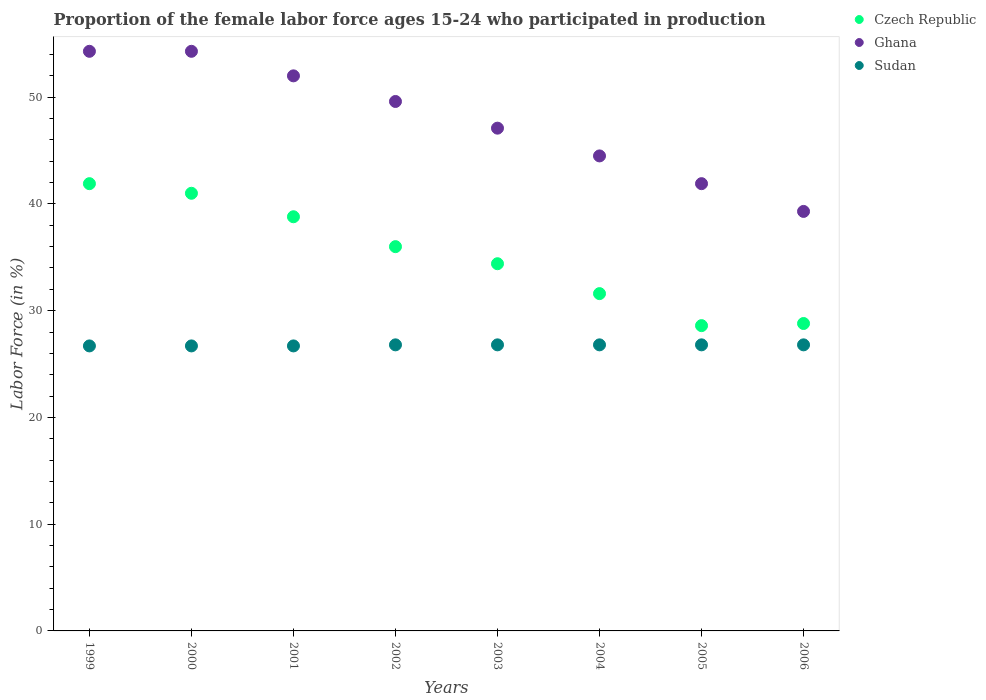What is the proportion of the female labor force who participated in production in Ghana in 2003?
Offer a very short reply. 47.1. Across all years, what is the maximum proportion of the female labor force who participated in production in Ghana?
Provide a succinct answer. 54.3. Across all years, what is the minimum proportion of the female labor force who participated in production in Ghana?
Your answer should be very brief. 39.3. What is the total proportion of the female labor force who participated in production in Czech Republic in the graph?
Your answer should be compact. 281.1. What is the difference between the proportion of the female labor force who participated in production in Ghana in 1999 and that in 2005?
Offer a terse response. 12.4. What is the difference between the proportion of the female labor force who participated in production in Sudan in 2000 and the proportion of the female labor force who participated in production in Ghana in 2005?
Keep it short and to the point. -15.2. What is the average proportion of the female labor force who participated in production in Ghana per year?
Offer a terse response. 47.87. In the year 2005, what is the difference between the proportion of the female labor force who participated in production in Czech Republic and proportion of the female labor force who participated in production in Sudan?
Give a very brief answer. 1.8. What is the ratio of the proportion of the female labor force who participated in production in Czech Republic in 2003 to that in 2004?
Provide a short and direct response. 1.09. What is the difference between the highest and the lowest proportion of the female labor force who participated in production in Ghana?
Make the answer very short. 15. Is it the case that in every year, the sum of the proportion of the female labor force who participated in production in Ghana and proportion of the female labor force who participated in production in Czech Republic  is greater than the proportion of the female labor force who participated in production in Sudan?
Offer a terse response. Yes. Is the proportion of the female labor force who participated in production in Czech Republic strictly greater than the proportion of the female labor force who participated in production in Sudan over the years?
Your answer should be very brief. Yes. How many years are there in the graph?
Ensure brevity in your answer.  8. What is the difference between two consecutive major ticks on the Y-axis?
Offer a very short reply. 10. Are the values on the major ticks of Y-axis written in scientific E-notation?
Provide a succinct answer. No. Does the graph contain grids?
Your response must be concise. No. Where does the legend appear in the graph?
Keep it short and to the point. Top right. How are the legend labels stacked?
Ensure brevity in your answer.  Vertical. What is the title of the graph?
Offer a very short reply. Proportion of the female labor force ages 15-24 who participated in production. What is the label or title of the X-axis?
Your answer should be compact. Years. What is the Labor Force (in %) of Czech Republic in 1999?
Keep it short and to the point. 41.9. What is the Labor Force (in %) of Ghana in 1999?
Provide a succinct answer. 54.3. What is the Labor Force (in %) of Sudan in 1999?
Provide a succinct answer. 26.7. What is the Labor Force (in %) in Ghana in 2000?
Make the answer very short. 54.3. What is the Labor Force (in %) in Sudan in 2000?
Give a very brief answer. 26.7. What is the Labor Force (in %) of Czech Republic in 2001?
Provide a short and direct response. 38.8. What is the Labor Force (in %) of Ghana in 2001?
Give a very brief answer. 52. What is the Labor Force (in %) of Sudan in 2001?
Keep it short and to the point. 26.7. What is the Labor Force (in %) in Ghana in 2002?
Keep it short and to the point. 49.6. What is the Labor Force (in %) in Sudan in 2002?
Offer a terse response. 26.8. What is the Labor Force (in %) in Czech Republic in 2003?
Ensure brevity in your answer.  34.4. What is the Labor Force (in %) in Ghana in 2003?
Ensure brevity in your answer.  47.1. What is the Labor Force (in %) in Sudan in 2003?
Give a very brief answer. 26.8. What is the Labor Force (in %) of Czech Republic in 2004?
Your answer should be compact. 31.6. What is the Labor Force (in %) in Ghana in 2004?
Your response must be concise. 44.5. What is the Labor Force (in %) of Sudan in 2004?
Keep it short and to the point. 26.8. What is the Labor Force (in %) of Czech Republic in 2005?
Provide a succinct answer. 28.6. What is the Labor Force (in %) of Ghana in 2005?
Your answer should be very brief. 41.9. What is the Labor Force (in %) in Sudan in 2005?
Provide a succinct answer. 26.8. What is the Labor Force (in %) of Czech Republic in 2006?
Ensure brevity in your answer.  28.8. What is the Labor Force (in %) in Ghana in 2006?
Offer a terse response. 39.3. What is the Labor Force (in %) in Sudan in 2006?
Provide a short and direct response. 26.8. Across all years, what is the maximum Labor Force (in %) of Czech Republic?
Give a very brief answer. 41.9. Across all years, what is the maximum Labor Force (in %) in Ghana?
Your response must be concise. 54.3. Across all years, what is the maximum Labor Force (in %) in Sudan?
Provide a short and direct response. 26.8. Across all years, what is the minimum Labor Force (in %) in Czech Republic?
Provide a short and direct response. 28.6. Across all years, what is the minimum Labor Force (in %) of Ghana?
Provide a short and direct response. 39.3. Across all years, what is the minimum Labor Force (in %) in Sudan?
Your answer should be compact. 26.7. What is the total Labor Force (in %) of Czech Republic in the graph?
Your response must be concise. 281.1. What is the total Labor Force (in %) of Ghana in the graph?
Ensure brevity in your answer.  383. What is the total Labor Force (in %) of Sudan in the graph?
Ensure brevity in your answer.  214.1. What is the difference between the Labor Force (in %) in Czech Republic in 1999 and that in 2000?
Ensure brevity in your answer.  0.9. What is the difference between the Labor Force (in %) in Ghana in 1999 and that in 2000?
Offer a terse response. 0. What is the difference between the Labor Force (in %) of Czech Republic in 1999 and that in 2001?
Provide a succinct answer. 3.1. What is the difference between the Labor Force (in %) in Ghana in 1999 and that in 2001?
Keep it short and to the point. 2.3. What is the difference between the Labor Force (in %) of Czech Republic in 1999 and that in 2002?
Provide a succinct answer. 5.9. What is the difference between the Labor Force (in %) of Ghana in 1999 and that in 2003?
Offer a very short reply. 7.2. What is the difference between the Labor Force (in %) of Sudan in 1999 and that in 2003?
Your answer should be very brief. -0.1. What is the difference between the Labor Force (in %) of Ghana in 1999 and that in 2005?
Give a very brief answer. 12.4. What is the difference between the Labor Force (in %) of Czech Republic in 1999 and that in 2006?
Provide a short and direct response. 13.1. What is the difference between the Labor Force (in %) in Sudan in 2000 and that in 2001?
Offer a very short reply. 0. What is the difference between the Labor Force (in %) in Czech Republic in 2000 and that in 2002?
Your answer should be compact. 5. What is the difference between the Labor Force (in %) of Ghana in 2000 and that in 2002?
Offer a terse response. 4.7. What is the difference between the Labor Force (in %) of Ghana in 2000 and that in 2003?
Give a very brief answer. 7.2. What is the difference between the Labor Force (in %) in Czech Republic in 2000 and that in 2004?
Your response must be concise. 9.4. What is the difference between the Labor Force (in %) in Sudan in 2000 and that in 2004?
Make the answer very short. -0.1. What is the difference between the Labor Force (in %) of Ghana in 2000 and that in 2005?
Your answer should be very brief. 12.4. What is the difference between the Labor Force (in %) in Czech Republic in 2000 and that in 2006?
Provide a succinct answer. 12.2. What is the difference between the Labor Force (in %) of Ghana in 2000 and that in 2006?
Keep it short and to the point. 15. What is the difference between the Labor Force (in %) of Sudan in 2000 and that in 2006?
Offer a terse response. -0.1. What is the difference between the Labor Force (in %) in Czech Republic in 2001 and that in 2002?
Give a very brief answer. 2.8. What is the difference between the Labor Force (in %) in Ghana in 2001 and that in 2002?
Offer a very short reply. 2.4. What is the difference between the Labor Force (in %) in Sudan in 2001 and that in 2002?
Your response must be concise. -0.1. What is the difference between the Labor Force (in %) in Czech Republic in 2001 and that in 2003?
Provide a short and direct response. 4.4. What is the difference between the Labor Force (in %) in Czech Republic in 2001 and that in 2004?
Give a very brief answer. 7.2. What is the difference between the Labor Force (in %) of Sudan in 2001 and that in 2004?
Give a very brief answer. -0.1. What is the difference between the Labor Force (in %) in Sudan in 2001 and that in 2005?
Provide a short and direct response. -0.1. What is the difference between the Labor Force (in %) of Sudan in 2001 and that in 2006?
Provide a succinct answer. -0.1. What is the difference between the Labor Force (in %) in Czech Republic in 2002 and that in 2003?
Give a very brief answer. 1.6. What is the difference between the Labor Force (in %) of Ghana in 2002 and that in 2003?
Your answer should be compact. 2.5. What is the difference between the Labor Force (in %) of Sudan in 2002 and that in 2003?
Provide a succinct answer. 0. What is the difference between the Labor Force (in %) of Czech Republic in 2002 and that in 2004?
Give a very brief answer. 4.4. What is the difference between the Labor Force (in %) of Sudan in 2002 and that in 2004?
Offer a very short reply. 0. What is the difference between the Labor Force (in %) in Czech Republic in 2002 and that in 2005?
Give a very brief answer. 7.4. What is the difference between the Labor Force (in %) in Sudan in 2002 and that in 2005?
Provide a short and direct response. 0. What is the difference between the Labor Force (in %) of Czech Republic in 2002 and that in 2006?
Keep it short and to the point. 7.2. What is the difference between the Labor Force (in %) in Sudan in 2002 and that in 2006?
Offer a terse response. 0. What is the difference between the Labor Force (in %) in Czech Republic in 2003 and that in 2004?
Offer a terse response. 2.8. What is the difference between the Labor Force (in %) in Ghana in 2003 and that in 2004?
Provide a short and direct response. 2.6. What is the difference between the Labor Force (in %) in Czech Republic in 2003 and that in 2005?
Give a very brief answer. 5.8. What is the difference between the Labor Force (in %) in Ghana in 2003 and that in 2005?
Offer a terse response. 5.2. What is the difference between the Labor Force (in %) of Sudan in 2003 and that in 2005?
Provide a succinct answer. 0. What is the difference between the Labor Force (in %) of Czech Republic in 2003 and that in 2006?
Provide a succinct answer. 5.6. What is the difference between the Labor Force (in %) of Ghana in 2003 and that in 2006?
Keep it short and to the point. 7.8. What is the difference between the Labor Force (in %) of Sudan in 2003 and that in 2006?
Your answer should be very brief. 0. What is the difference between the Labor Force (in %) in Czech Republic in 2004 and that in 2006?
Your response must be concise. 2.8. What is the difference between the Labor Force (in %) in Sudan in 2004 and that in 2006?
Provide a short and direct response. 0. What is the difference between the Labor Force (in %) in Ghana in 2005 and that in 2006?
Offer a very short reply. 2.6. What is the difference between the Labor Force (in %) of Czech Republic in 1999 and the Labor Force (in %) of Sudan in 2000?
Your response must be concise. 15.2. What is the difference between the Labor Force (in %) of Ghana in 1999 and the Labor Force (in %) of Sudan in 2000?
Give a very brief answer. 27.6. What is the difference between the Labor Force (in %) in Ghana in 1999 and the Labor Force (in %) in Sudan in 2001?
Offer a very short reply. 27.6. What is the difference between the Labor Force (in %) in Czech Republic in 1999 and the Labor Force (in %) in Sudan in 2002?
Make the answer very short. 15.1. What is the difference between the Labor Force (in %) in Czech Republic in 1999 and the Labor Force (in %) in Ghana in 2004?
Your answer should be very brief. -2.6. What is the difference between the Labor Force (in %) of Czech Republic in 1999 and the Labor Force (in %) of Sudan in 2004?
Give a very brief answer. 15.1. What is the difference between the Labor Force (in %) in Ghana in 1999 and the Labor Force (in %) in Sudan in 2004?
Keep it short and to the point. 27.5. What is the difference between the Labor Force (in %) of Czech Republic in 1999 and the Labor Force (in %) of Ghana in 2005?
Give a very brief answer. 0. What is the difference between the Labor Force (in %) in Czech Republic in 1999 and the Labor Force (in %) in Sudan in 2005?
Provide a succinct answer. 15.1. What is the difference between the Labor Force (in %) in Ghana in 1999 and the Labor Force (in %) in Sudan in 2005?
Give a very brief answer. 27.5. What is the difference between the Labor Force (in %) of Czech Republic in 1999 and the Labor Force (in %) of Sudan in 2006?
Make the answer very short. 15.1. What is the difference between the Labor Force (in %) of Ghana in 1999 and the Labor Force (in %) of Sudan in 2006?
Give a very brief answer. 27.5. What is the difference between the Labor Force (in %) in Czech Republic in 2000 and the Labor Force (in %) in Ghana in 2001?
Ensure brevity in your answer.  -11. What is the difference between the Labor Force (in %) of Ghana in 2000 and the Labor Force (in %) of Sudan in 2001?
Your response must be concise. 27.6. What is the difference between the Labor Force (in %) in Czech Republic in 2000 and the Labor Force (in %) in Ghana in 2003?
Provide a succinct answer. -6.1. What is the difference between the Labor Force (in %) in Czech Republic in 2000 and the Labor Force (in %) in Ghana in 2004?
Ensure brevity in your answer.  -3.5. What is the difference between the Labor Force (in %) of Czech Republic in 2000 and the Labor Force (in %) of Ghana in 2005?
Provide a short and direct response. -0.9. What is the difference between the Labor Force (in %) in Czech Republic in 2000 and the Labor Force (in %) in Ghana in 2006?
Provide a short and direct response. 1.7. What is the difference between the Labor Force (in %) in Czech Republic in 2000 and the Labor Force (in %) in Sudan in 2006?
Ensure brevity in your answer.  14.2. What is the difference between the Labor Force (in %) in Ghana in 2000 and the Labor Force (in %) in Sudan in 2006?
Keep it short and to the point. 27.5. What is the difference between the Labor Force (in %) of Czech Republic in 2001 and the Labor Force (in %) of Ghana in 2002?
Your response must be concise. -10.8. What is the difference between the Labor Force (in %) of Ghana in 2001 and the Labor Force (in %) of Sudan in 2002?
Provide a short and direct response. 25.2. What is the difference between the Labor Force (in %) in Czech Republic in 2001 and the Labor Force (in %) in Sudan in 2003?
Offer a terse response. 12. What is the difference between the Labor Force (in %) in Ghana in 2001 and the Labor Force (in %) in Sudan in 2003?
Your answer should be compact. 25.2. What is the difference between the Labor Force (in %) in Czech Republic in 2001 and the Labor Force (in %) in Ghana in 2004?
Give a very brief answer. -5.7. What is the difference between the Labor Force (in %) in Ghana in 2001 and the Labor Force (in %) in Sudan in 2004?
Your answer should be very brief. 25.2. What is the difference between the Labor Force (in %) of Czech Republic in 2001 and the Labor Force (in %) of Ghana in 2005?
Provide a succinct answer. -3.1. What is the difference between the Labor Force (in %) in Ghana in 2001 and the Labor Force (in %) in Sudan in 2005?
Ensure brevity in your answer.  25.2. What is the difference between the Labor Force (in %) of Ghana in 2001 and the Labor Force (in %) of Sudan in 2006?
Ensure brevity in your answer.  25.2. What is the difference between the Labor Force (in %) in Czech Republic in 2002 and the Labor Force (in %) in Ghana in 2003?
Provide a short and direct response. -11.1. What is the difference between the Labor Force (in %) in Czech Republic in 2002 and the Labor Force (in %) in Sudan in 2003?
Your answer should be very brief. 9.2. What is the difference between the Labor Force (in %) in Ghana in 2002 and the Labor Force (in %) in Sudan in 2003?
Keep it short and to the point. 22.8. What is the difference between the Labor Force (in %) of Ghana in 2002 and the Labor Force (in %) of Sudan in 2004?
Provide a succinct answer. 22.8. What is the difference between the Labor Force (in %) of Czech Republic in 2002 and the Labor Force (in %) of Sudan in 2005?
Your answer should be very brief. 9.2. What is the difference between the Labor Force (in %) in Ghana in 2002 and the Labor Force (in %) in Sudan in 2005?
Ensure brevity in your answer.  22.8. What is the difference between the Labor Force (in %) in Czech Republic in 2002 and the Labor Force (in %) in Ghana in 2006?
Offer a terse response. -3.3. What is the difference between the Labor Force (in %) in Ghana in 2002 and the Labor Force (in %) in Sudan in 2006?
Your answer should be compact. 22.8. What is the difference between the Labor Force (in %) in Czech Republic in 2003 and the Labor Force (in %) in Ghana in 2004?
Give a very brief answer. -10.1. What is the difference between the Labor Force (in %) in Ghana in 2003 and the Labor Force (in %) in Sudan in 2004?
Give a very brief answer. 20.3. What is the difference between the Labor Force (in %) in Czech Republic in 2003 and the Labor Force (in %) in Sudan in 2005?
Keep it short and to the point. 7.6. What is the difference between the Labor Force (in %) of Ghana in 2003 and the Labor Force (in %) of Sudan in 2005?
Offer a terse response. 20.3. What is the difference between the Labor Force (in %) in Czech Republic in 2003 and the Labor Force (in %) in Sudan in 2006?
Keep it short and to the point. 7.6. What is the difference between the Labor Force (in %) of Ghana in 2003 and the Labor Force (in %) of Sudan in 2006?
Make the answer very short. 20.3. What is the difference between the Labor Force (in %) in Czech Republic in 2004 and the Labor Force (in %) in Sudan in 2005?
Your response must be concise. 4.8. What is the difference between the Labor Force (in %) of Ghana in 2004 and the Labor Force (in %) of Sudan in 2005?
Give a very brief answer. 17.7. What is the difference between the Labor Force (in %) in Czech Republic in 2004 and the Labor Force (in %) in Ghana in 2006?
Offer a very short reply. -7.7. What is the difference between the Labor Force (in %) of Ghana in 2004 and the Labor Force (in %) of Sudan in 2006?
Your response must be concise. 17.7. What is the difference between the Labor Force (in %) in Czech Republic in 2005 and the Labor Force (in %) in Ghana in 2006?
Make the answer very short. -10.7. What is the average Labor Force (in %) in Czech Republic per year?
Your response must be concise. 35.14. What is the average Labor Force (in %) in Ghana per year?
Ensure brevity in your answer.  47.88. What is the average Labor Force (in %) in Sudan per year?
Provide a short and direct response. 26.76. In the year 1999, what is the difference between the Labor Force (in %) in Czech Republic and Labor Force (in %) in Ghana?
Your answer should be very brief. -12.4. In the year 1999, what is the difference between the Labor Force (in %) of Czech Republic and Labor Force (in %) of Sudan?
Your answer should be compact. 15.2. In the year 1999, what is the difference between the Labor Force (in %) of Ghana and Labor Force (in %) of Sudan?
Keep it short and to the point. 27.6. In the year 2000, what is the difference between the Labor Force (in %) of Czech Republic and Labor Force (in %) of Ghana?
Make the answer very short. -13.3. In the year 2000, what is the difference between the Labor Force (in %) in Czech Republic and Labor Force (in %) in Sudan?
Offer a terse response. 14.3. In the year 2000, what is the difference between the Labor Force (in %) of Ghana and Labor Force (in %) of Sudan?
Give a very brief answer. 27.6. In the year 2001, what is the difference between the Labor Force (in %) of Czech Republic and Labor Force (in %) of Ghana?
Give a very brief answer. -13.2. In the year 2001, what is the difference between the Labor Force (in %) of Ghana and Labor Force (in %) of Sudan?
Offer a very short reply. 25.3. In the year 2002, what is the difference between the Labor Force (in %) of Czech Republic and Labor Force (in %) of Ghana?
Keep it short and to the point. -13.6. In the year 2002, what is the difference between the Labor Force (in %) in Ghana and Labor Force (in %) in Sudan?
Offer a terse response. 22.8. In the year 2003, what is the difference between the Labor Force (in %) of Ghana and Labor Force (in %) of Sudan?
Provide a short and direct response. 20.3. In the year 2004, what is the difference between the Labor Force (in %) of Czech Republic and Labor Force (in %) of Ghana?
Give a very brief answer. -12.9. In the year 2005, what is the difference between the Labor Force (in %) of Czech Republic and Labor Force (in %) of Ghana?
Make the answer very short. -13.3. In the year 2005, what is the difference between the Labor Force (in %) of Czech Republic and Labor Force (in %) of Sudan?
Your answer should be compact. 1.8. In the year 2005, what is the difference between the Labor Force (in %) of Ghana and Labor Force (in %) of Sudan?
Your answer should be very brief. 15.1. In the year 2006, what is the difference between the Labor Force (in %) in Czech Republic and Labor Force (in %) in Ghana?
Ensure brevity in your answer.  -10.5. In the year 2006, what is the difference between the Labor Force (in %) of Ghana and Labor Force (in %) of Sudan?
Keep it short and to the point. 12.5. What is the ratio of the Labor Force (in %) in Czech Republic in 1999 to that in 2000?
Make the answer very short. 1.02. What is the ratio of the Labor Force (in %) of Sudan in 1999 to that in 2000?
Provide a short and direct response. 1. What is the ratio of the Labor Force (in %) in Czech Republic in 1999 to that in 2001?
Ensure brevity in your answer.  1.08. What is the ratio of the Labor Force (in %) in Ghana in 1999 to that in 2001?
Your response must be concise. 1.04. What is the ratio of the Labor Force (in %) in Sudan in 1999 to that in 2001?
Your answer should be very brief. 1. What is the ratio of the Labor Force (in %) in Czech Republic in 1999 to that in 2002?
Ensure brevity in your answer.  1.16. What is the ratio of the Labor Force (in %) of Ghana in 1999 to that in 2002?
Make the answer very short. 1.09. What is the ratio of the Labor Force (in %) in Sudan in 1999 to that in 2002?
Make the answer very short. 1. What is the ratio of the Labor Force (in %) in Czech Republic in 1999 to that in 2003?
Keep it short and to the point. 1.22. What is the ratio of the Labor Force (in %) of Ghana in 1999 to that in 2003?
Provide a short and direct response. 1.15. What is the ratio of the Labor Force (in %) in Sudan in 1999 to that in 2003?
Provide a short and direct response. 1. What is the ratio of the Labor Force (in %) in Czech Republic in 1999 to that in 2004?
Your answer should be compact. 1.33. What is the ratio of the Labor Force (in %) in Ghana in 1999 to that in 2004?
Provide a succinct answer. 1.22. What is the ratio of the Labor Force (in %) in Czech Republic in 1999 to that in 2005?
Ensure brevity in your answer.  1.47. What is the ratio of the Labor Force (in %) in Ghana in 1999 to that in 2005?
Ensure brevity in your answer.  1.3. What is the ratio of the Labor Force (in %) in Czech Republic in 1999 to that in 2006?
Your answer should be very brief. 1.45. What is the ratio of the Labor Force (in %) of Ghana in 1999 to that in 2006?
Offer a very short reply. 1.38. What is the ratio of the Labor Force (in %) of Sudan in 1999 to that in 2006?
Provide a succinct answer. 1. What is the ratio of the Labor Force (in %) of Czech Republic in 2000 to that in 2001?
Your response must be concise. 1.06. What is the ratio of the Labor Force (in %) in Ghana in 2000 to that in 2001?
Your answer should be compact. 1.04. What is the ratio of the Labor Force (in %) in Czech Republic in 2000 to that in 2002?
Give a very brief answer. 1.14. What is the ratio of the Labor Force (in %) in Ghana in 2000 to that in 2002?
Keep it short and to the point. 1.09. What is the ratio of the Labor Force (in %) of Czech Republic in 2000 to that in 2003?
Ensure brevity in your answer.  1.19. What is the ratio of the Labor Force (in %) of Ghana in 2000 to that in 2003?
Provide a short and direct response. 1.15. What is the ratio of the Labor Force (in %) of Czech Republic in 2000 to that in 2004?
Your response must be concise. 1.3. What is the ratio of the Labor Force (in %) of Ghana in 2000 to that in 2004?
Your answer should be compact. 1.22. What is the ratio of the Labor Force (in %) in Sudan in 2000 to that in 2004?
Give a very brief answer. 1. What is the ratio of the Labor Force (in %) of Czech Republic in 2000 to that in 2005?
Offer a very short reply. 1.43. What is the ratio of the Labor Force (in %) in Ghana in 2000 to that in 2005?
Your answer should be very brief. 1.3. What is the ratio of the Labor Force (in %) in Czech Republic in 2000 to that in 2006?
Make the answer very short. 1.42. What is the ratio of the Labor Force (in %) of Ghana in 2000 to that in 2006?
Keep it short and to the point. 1.38. What is the ratio of the Labor Force (in %) of Sudan in 2000 to that in 2006?
Provide a succinct answer. 1. What is the ratio of the Labor Force (in %) of Czech Republic in 2001 to that in 2002?
Offer a very short reply. 1.08. What is the ratio of the Labor Force (in %) of Ghana in 2001 to that in 2002?
Give a very brief answer. 1.05. What is the ratio of the Labor Force (in %) in Sudan in 2001 to that in 2002?
Offer a terse response. 1. What is the ratio of the Labor Force (in %) in Czech Republic in 2001 to that in 2003?
Your answer should be very brief. 1.13. What is the ratio of the Labor Force (in %) in Ghana in 2001 to that in 2003?
Offer a terse response. 1.1. What is the ratio of the Labor Force (in %) in Czech Republic in 2001 to that in 2004?
Provide a succinct answer. 1.23. What is the ratio of the Labor Force (in %) in Ghana in 2001 to that in 2004?
Offer a terse response. 1.17. What is the ratio of the Labor Force (in %) of Czech Republic in 2001 to that in 2005?
Your answer should be very brief. 1.36. What is the ratio of the Labor Force (in %) in Ghana in 2001 to that in 2005?
Give a very brief answer. 1.24. What is the ratio of the Labor Force (in %) of Czech Republic in 2001 to that in 2006?
Offer a very short reply. 1.35. What is the ratio of the Labor Force (in %) in Ghana in 2001 to that in 2006?
Ensure brevity in your answer.  1.32. What is the ratio of the Labor Force (in %) of Czech Republic in 2002 to that in 2003?
Ensure brevity in your answer.  1.05. What is the ratio of the Labor Force (in %) in Ghana in 2002 to that in 2003?
Your answer should be compact. 1.05. What is the ratio of the Labor Force (in %) in Czech Republic in 2002 to that in 2004?
Keep it short and to the point. 1.14. What is the ratio of the Labor Force (in %) in Ghana in 2002 to that in 2004?
Provide a short and direct response. 1.11. What is the ratio of the Labor Force (in %) of Czech Republic in 2002 to that in 2005?
Offer a very short reply. 1.26. What is the ratio of the Labor Force (in %) in Ghana in 2002 to that in 2005?
Provide a short and direct response. 1.18. What is the ratio of the Labor Force (in %) in Ghana in 2002 to that in 2006?
Keep it short and to the point. 1.26. What is the ratio of the Labor Force (in %) in Czech Republic in 2003 to that in 2004?
Make the answer very short. 1.09. What is the ratio of the Labor Force (in %) in Ghana in 2003 to that in 2004?
Your response must be concise. 1.06. What is the ratio of the Labor Force (in %) of Sudan in 2003 to that in 2004?
Make the answer very short. 1. What is the ratio of the Labor Force (in %) of Czech Republic in 2003 to that in 2005?
Give a very brief answer. 1.2. What is the ratio of the Labor Force (in %) of Ghana in 2003 to that in 2005?
Your answer should be compact. 1.12. What is the ratio of the Labor Force (in %) in Czech Republic in 2003 to that in 2006?
Your answer should be very brief. 1.19. What is the ratio of the Labor Force (in %) in Ghana in 2003 to that in 2006?
Your response must be concise. 1.2. What is the ratio of the Labor Force (in %) of Sudan in 2003 to that in 2006?
Provide a short and direct response. 1. What is the ratio of the Labor Force (in %) of Czech Republic in 2004 to that in 2005?
Give a very brief answer. 1.1. What is the ratio of the Labor Force (in %) in Ghana in 2004 to that in 2005?
Keep it short and to the point. 1.06. What is the ratio of the Labor Force (in %) in Czech Republic in 2004 to that in 2006?
Your response must be concise. 1.1. What is the ratio of the Labor Force (in %) in Ghana in 2004 to that in 2006?
Your response must be concise. 1.13. What is the ratio of the Labor Force (in %) of Ghana in 2005 to that in 2006?
Your answer should be compact. 1.07. What is the difference between the highest and the second highest Labor Force (in %) of Ghana?
Make the answer very short. 0. What is the difference between the highest and the second highest Labor Force (in %) in Sudan?
Ensure brevity in your answer.  0. What is the difference between the highest and the lowest Labor Force (in %) in Czech Republic?
Offer a very short reply. 13.3. What is the difference between the highest and the lowest Labor Force (in %) of Sudan?
Provide a short and direct response. 0.1. 